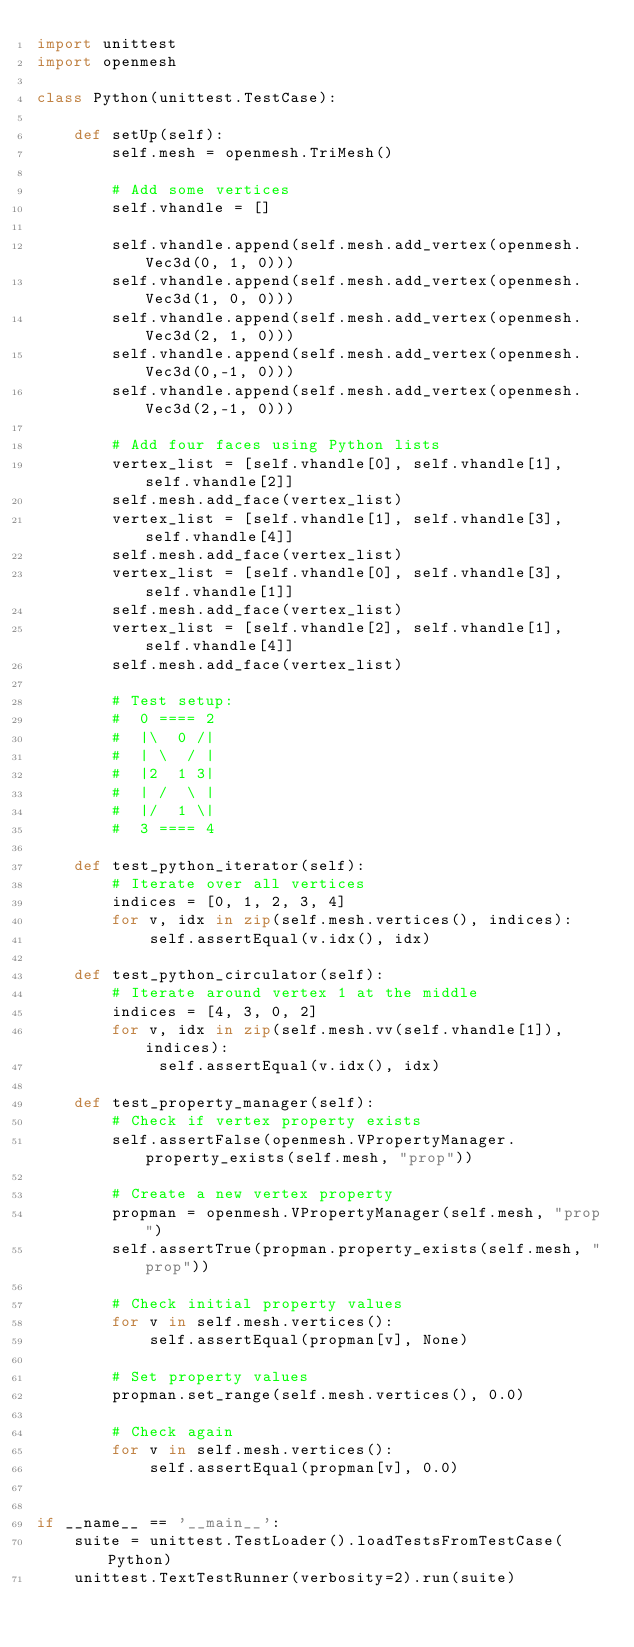Convert code to text. <code><loc_0><loc_0><loc_500><loc_500><_Python_>import unittest
import openmesh

class Python(unittest.TestCase):

    def setUp(self):
        self.mesh = openmesh.TriMesh()

        # Add some vertices
        self.vhandle = []

        self.vhandle.append(self.mesh.add_vertex(openmesh.Vec3d(0, 1, 0)))
        self.vhandle.append(self.mesh.add_vertex(openmesh.Vec3d(1, 0, 0)))
        self.vhandle.append(self.mesh.add_vertex(openmesh.Vec3d(2, 1, 0)))
        self.vhandle.append(self.mesh.add_vertex(openmesh.Vec3d(0,-1, 0)))
        self.vhandle.append(self.mesh.add_vertex(openmesh.Vec3d(2,-1, 0)))

        # Add four faces using Python lists
        vertex_list = [self.vhandle[0], self.vhandle[1], self.vhandle[2]]
        self.mesh.add_face(vertex_list)
        vertex_list = [self.vhandle[1], self.vhandle[3], self.vhandle[4]]
        self.mesh.add_face(vertex_list)
        vertex_list = [self.vhandle[0], self.vhandle[3], self.vhandle[1]]
        self.mesh.add_face(vertex_list)
        vertex_list = [self.vhandle[2], self.vhandle[1], self.vhandle[4]]
        self.mesh.add_face(vertex_list)

        # Test setup:
        #  0 ==== 2
        #  |\  0 /|
        #  | \  / |
        #  |2  1 3|
        #  | /  \ |
        #  |/  1 \|
        #  3 ==== 4
        
    def test_python_iterator(self):
        # Iterate over all vertices
        indices = [0, 1, 2, 3, 4]
        for v, idx in zip(self.mesh.vertices(), indices):
            self.assertEqual(v.idx(), idx)

    def test_python_circulator(self):
        # Iterate around vertex 1 at the middle
        indices = [4, 3, 0, 2]
        for v, idx in zip(self.mesh.vv(self.vhandle[1]), indices):
             self.assertEqual(v.idx(), idx)

    def test_property_manager(self):
        # Check if vertex property exists
        self.assertFalse(openmesh.VPropertyManager.property_exists(self.mesh, "prop"))
        
        # Create a new vertex property
        propman = openmesh.VPropertyManager(self.mesh, "prop")
        self.assertTrue(propman.property_exists(self.mesh, "prop"))
        
        # Check initial property values
        for v in self.mesh.vertices():
            self.assertEqual(propman[v], None)
        
        # Set property values
        propman.set_range(self.mesh.vertices(), 0.0)
        
        # Check again
        for v in self.mesh.vertices():
            self.assertEqual(propman[v], 0.0)


if __name__ == '__main__':
    suite = unittest.TestLoader().loadTestsFromTestCase(Python)
    unittest.TextTestRunner(verbosity=2).run(suite)
</code> 